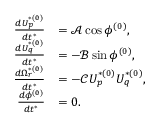<formula> <loc_0><loc_0><loc_500><loc_500>\begin{array} { r l } { \frac { d U _ { p } ^ { * ( 0 ) } } { d t ^ { * } } } & { = \mathcal { A } \cos \phi ^ { ( 0 ) } , } \\ { \frac { d U _ { q } ^ { * ( 0 ) } } { d t ^ { * } } } & { = - \mathcal { B } \sin \phi ^ { ( 0 ) } , } \\ { \frac { d \Omega _ { r } ^ { * ( 0 ) } } { d t ^ { * } } } & { = - \mathcal { C } U _ { p } ^ { * ( 0 ) } U _ { q } ^ { * ( 0 ) } , } \\ { \frac { d \phi ^ { ( 0 ) } } { d t ^ { * } } } & { = 0 . } \end{array}</formula> 